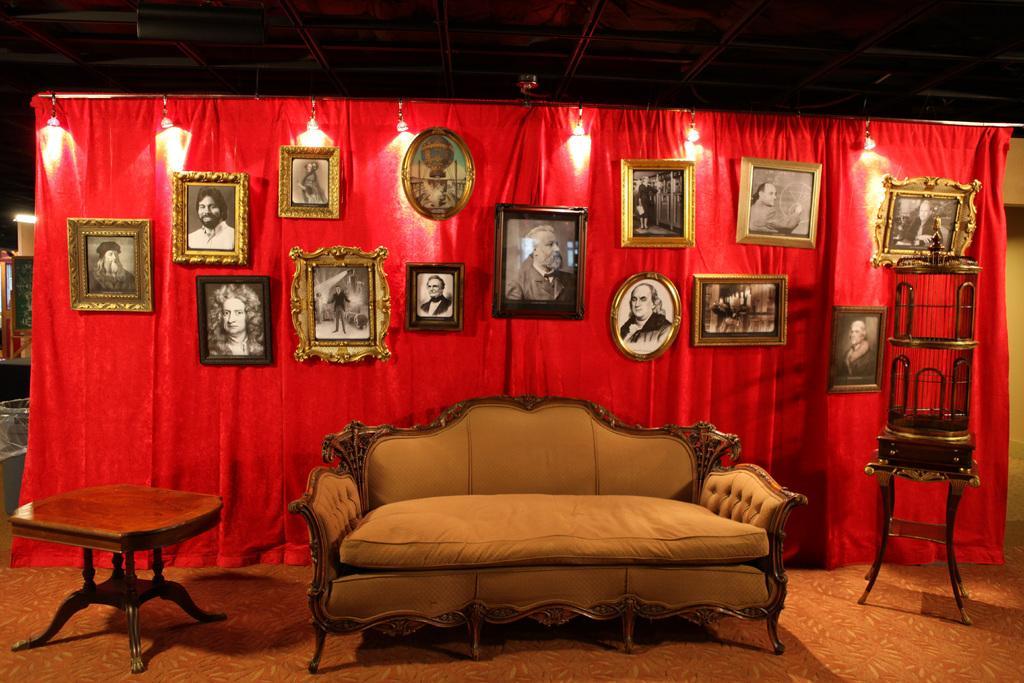Can you describe this image briefly? There is a sofa with a table beside it. There are photo frames hanging on to a red color screen in the background. 